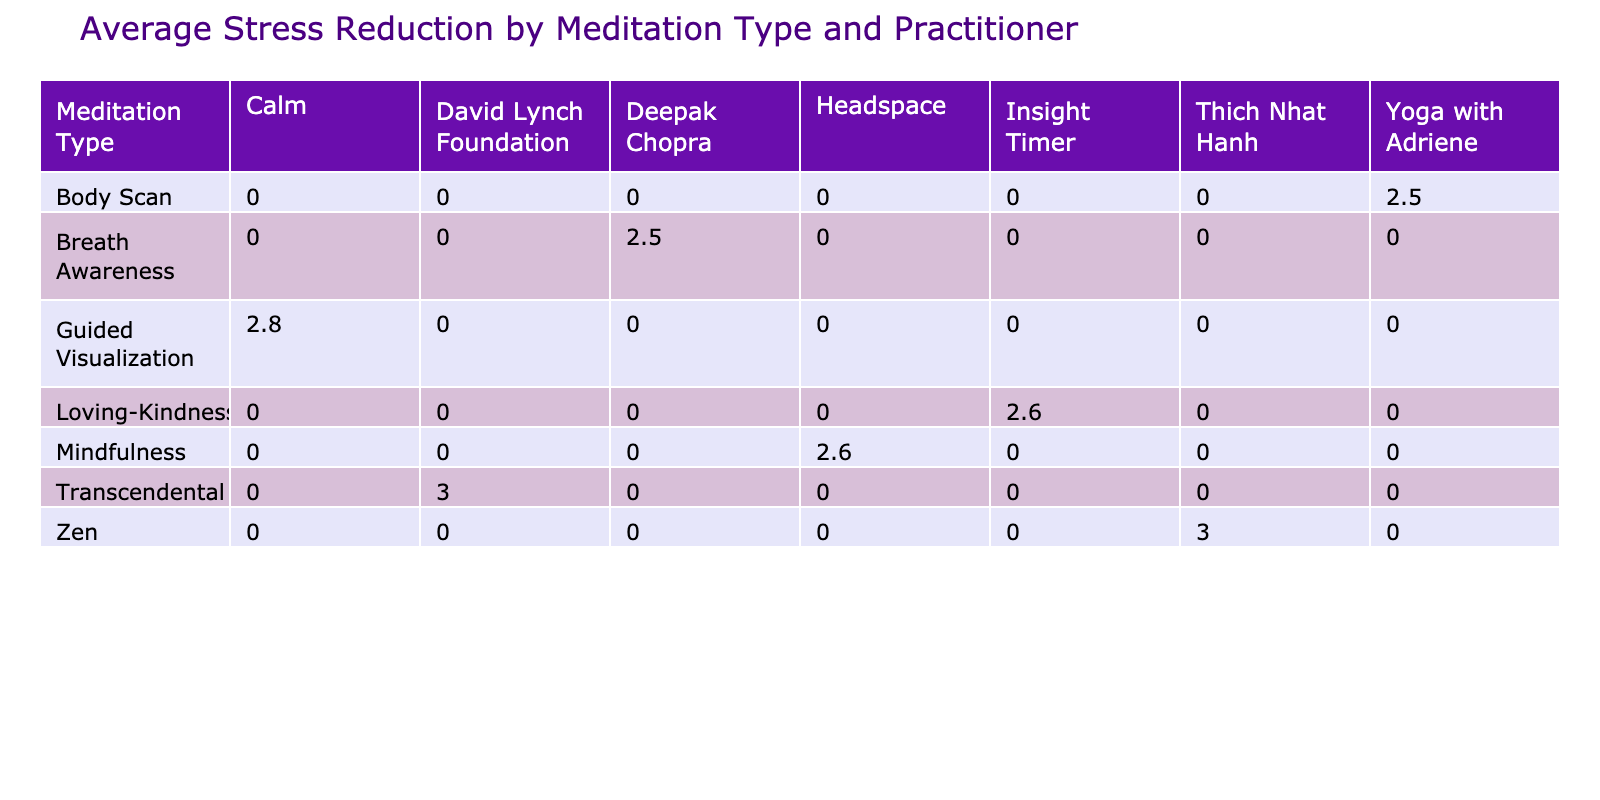What is the average stress reduction for Mindfulness meditation? According to the table, the stress reduction for Mindfulness meditation across different practitioners is calculated from those rows. Summing up the stress reductions gives: (2 + 2 + 3 + 3 + 3) = 13 and there are 5 entries. Therefore, the average is 13/5 = 2.6.
Answer: 2.6 Which meditation type had the highest average stress reduction? By looking across the average stress reductions for all meditation types, I find that "Loving-Kindness" has the following values: (2 + 2 + 3)/3 = 2.33. For "Mindfulness", it is 2.6 as calculated previously. For others, "Body Scan" is 2 (2 + 2)/2, "Guided Visualization" is 1.33, and "Zen" is 2. The highest is thus for "Mindfulness" with 2.6.
Answer: Mindfulness Was there any practitioner that consistently reduced stress levels for all meditation types? By reviewing the table, we see that the practitioners listed each have varying stress reduction values across the meditation types. For example, Headspace has stress reductions of (2, 2, 3) for Mindfulness, while Insight Timer has (2, 2, 2). Therefore, no practitioner shows consistent reductions across all types, leading to a conclusion of no.
Answer: No What is the total stress reduction from all meditation practices combined? To find this, I sum all the stress reduction values across each meditation entry in the table: 2 + 2 + 2 + 2 + 2 + 3 + 2 + 2 + 2 + 1 + 2 + 3 + 3 + 4 + 2 + 2 + 3 + 2 + 2 + 2 + 2 + 3 + 2 = 43. The sum gives the total stress reduction from all practices.
Answer: 43 Did the "Zen" meditation have a higher average stress reduction than "Transcendental"? First, I note the stress reductions for "Zen": (3 + 4 + 4 + 4)/4 = 3.75. Then for "Transcendental": (3 + 2 + 3 + 2)/4 = 2.5. Comparing these averages reveals that 3.75 > 2.5. Therefore, "Zen" performed better in reducing stress levels on average than "Transcendental."
Answer: Yes 